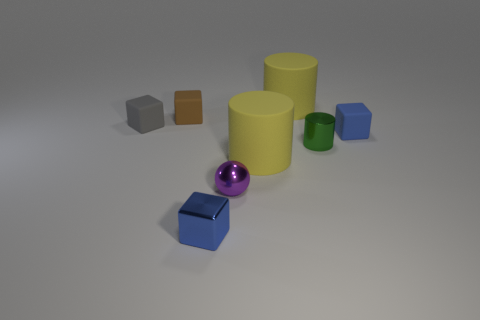Subtract all gray cubes. How many cubes are left? 3 Subtract all yellow cubes. Subtract all gray spheres. How many cubes are left? 4 Add 1 small blue things. How many objects exist? 9 Subtract all spheres. How many objects are left? 7 Add 3 tiny purple spheres. How many tiny purple spheres exist? 4 Subtract 0 brown cylinders. How many objects are left? 8 Subtract all big purple metal cylinders. Subtract all matte things. How many objects are left? 3 Add 7 tiny metallic objects. How many tiny metallic objects are left? 10 